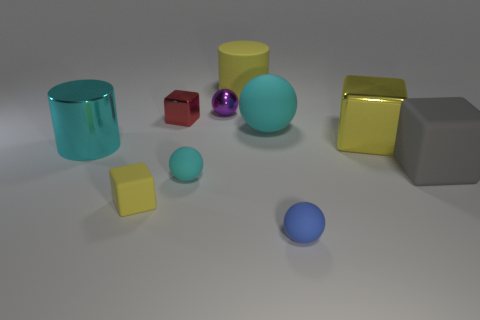Subtract 1 spheres. How many spheres are left? 3 Subtract all purple cubes. Subtract all gray cylinders. How many cubes are left? 4 Subtract all cubes. How many objects are left? 6 Subtract all large yellow things. Subtract all blue matte things. How many objects are left? 7 Add 6 small cyan rubber objects. How many small cyan rubber objects are left? 7 Add 4 gray rubber blocks. How many gray rubber blocks exist? 5 Subtract 1 yellow cylinders. How many objects are left? 9 